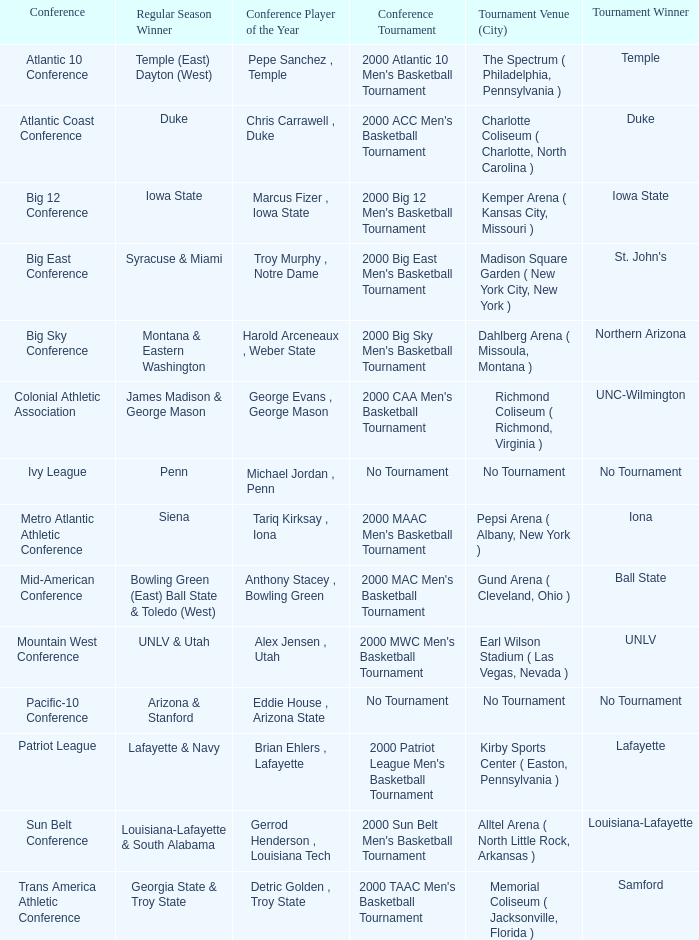Where was the ivy league tournament held? No Tournament. Could you parse the entire table as a dict? {'header': ['Conference', 'Regular Season Winner', 'Conference Player of the Year', 'Conference Tournament', 'Tournament Venue (City)', 'Tournament Winner'], 'rows': [['Atlantic 10 Conference', 'Temple (East) Dayton (West)', 'Pepe Sanchez , Temple', "2000 Atlantic 10 Men's Basketball Tournament", 'The Spectrum ( Philadelphia, Pennsylvania )', 'Temple'], ['Atlantic Coast Conference', 'Duke', 'Chris Carrawell , Duke', "2000 ACC Men's Basketball Tournament", 'Charlotte Coliseum ( Charlotte, North Carolina )', 'Duke'], ['Big 12 Conference', 'Iowa State', 'Marcus Fizer , Iowa State', "2000 Big 12 Men's Basketball Tournament", 'Kemper Arena ( Kansas City, Missouri )', 'Iowa State'], ['Big East Conference', 'Syracuse & Miami', 'Troy Murphy , Notre Dame', "2000 Big East Men's Basketball Tournament", 'Madison Square Garden ( New York City, New York )', "St. John's"], ['Big Sky Conference', 'Montana & Eastern Washington', 'Harold Arceneaux , Weber State', "2000 Big Sky Men's Basketball Tournament", 'Dahlberg Arena ( Missoula, Montana )', 'Northern Arizona'], ['Colonial Athletic Association', 'James Madison & George Mason', 'George Evans , George Mason', "2000 CAA Men's Basketball Tournament", 'Richmond Coliseum ( Richmond, Virginia )', 'UNC-Wilmington'], ['Ivy League', 'Penn', 'Michael Jordan , Penn', 'No Tournament', 'No Tournament', 'No Tournament'], ['Metro Atlantic Athletic Conference', 'Siena', 'Tariq Kirksay , Iona', "2000 MAAC Men's Basketball Tournament", 'Pepsi Arena ( Albany, New York )', 'Iona'], ['Mid-American Conference', 'Bowling Green (East) Ball State & Toledo (West)', 'Anthony Stacey , Bowling Green', "2000 MAC Men's Basketball Tournament", 'Gund Arena ( Cleveland, Ohio )', 'Ball State'], ['Mountain West Conference', 'UNLV & Utah', 'Alex Jensen , Utah', "2000 MWC Men's Basketball Tournament", 'Earl Wilson Stadium ( Las Vegas, Nevada )', 'UNLV'], ['Pacific-10 Conference', 'Arizona & Stanford', 'Eddie House , Arizona State', 'No Tournament', 'No Tournament', 'No Tournament'], ['Patriot League', 'Lafayette & Navy', 'Brian Ehlers , Lafayette', "2000 Patriot League Men's Basketball Tournament", 'Kirby Sports Center ( Easton, Pennsylvania )', 'Lafayette'], ['Sun Belt Conference', 'Louisiana-Lafayette & South Alabama', 'Gerrod Henderson , Louisiana Tech', "2000 Sun Belt Men's Basketball Tournament", 'Alltel Arena ( North Little Rock, Arkansas )', 'Louisiana-Lafayette'], ['Trans America Athletic Conference', 'Georgia State & Troy State', 'Detric Golden , Troy State', "2000 TAAC Men's Basketball Tournament", 'Memorial Coliseum ( Jacksonville, Florida )', 'Samford']]} 